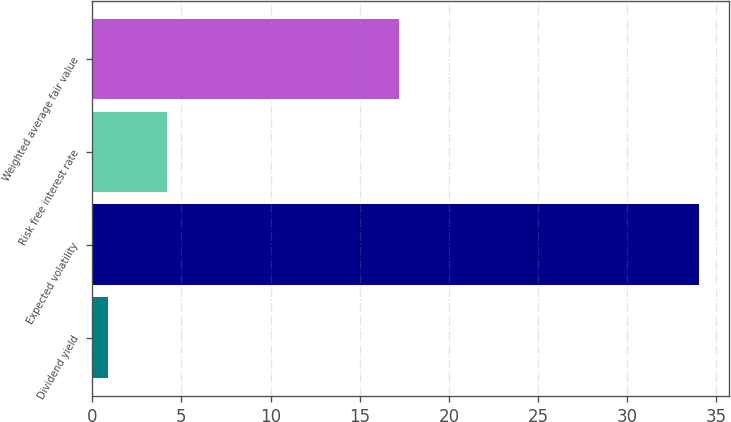<chart> <loc_0><loc_0><loc_500><loc_500><bar_chart><fcel>Dividend yield<fcel>Expected volatility<fcel>Risk free interest rate<fcel>Weighted average fair value<nl><fcel>0.9<fcel>34<fcel>4.21<fcel>17.21<nl></chart> 